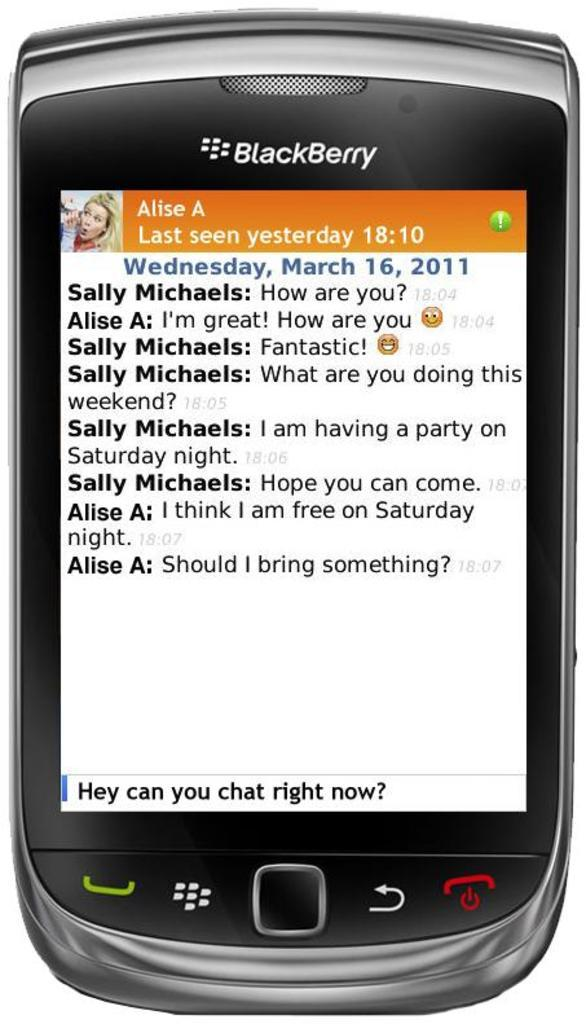<image>
Summarize the visual content of the image. A BlackBerry is in focus and showing a text conversation about party plans for the weekend. 